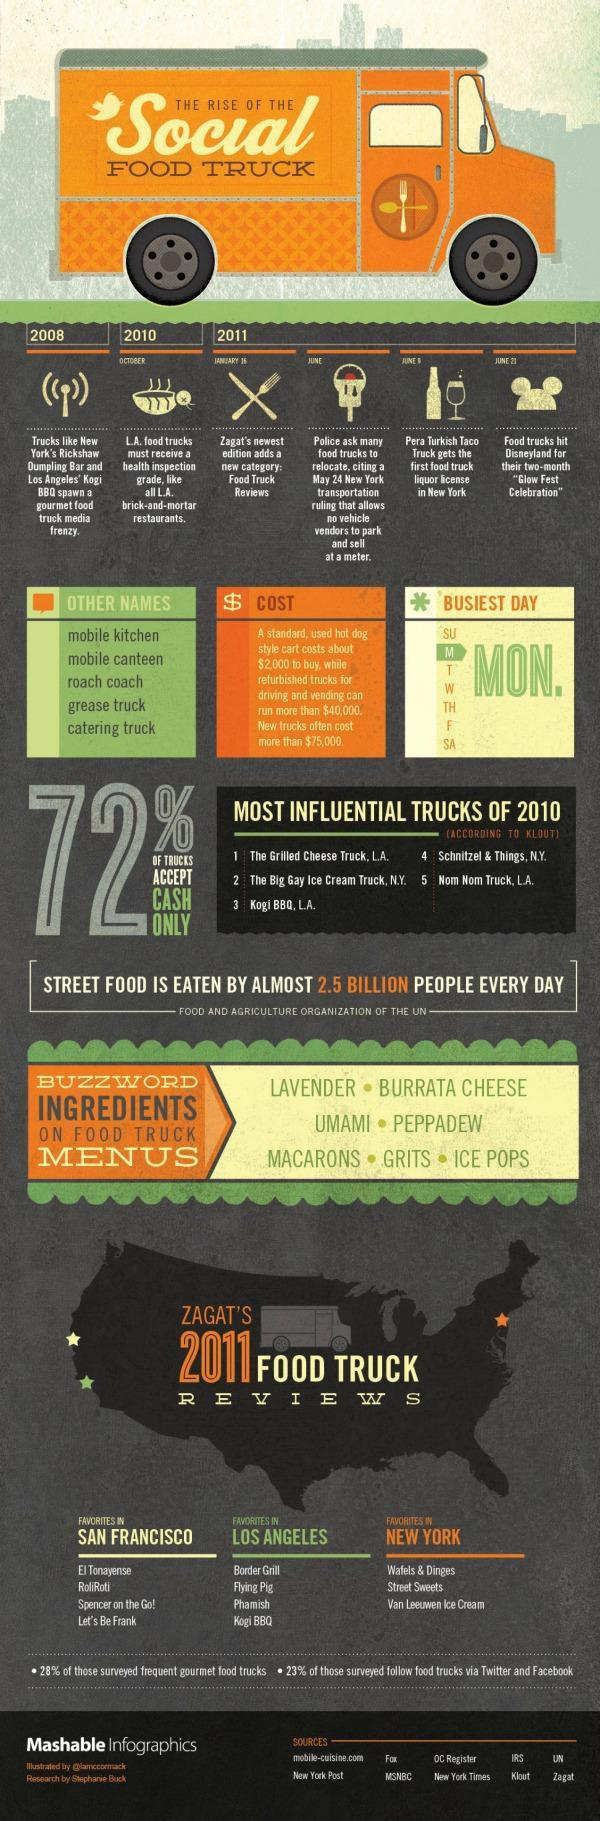In which year, Zagat's newest edition adds a new category called 'Food Truck Reviews'?
Answer the question with a short phrase. 2011 Which is the busiest day in a week for the food trucks? MON. 